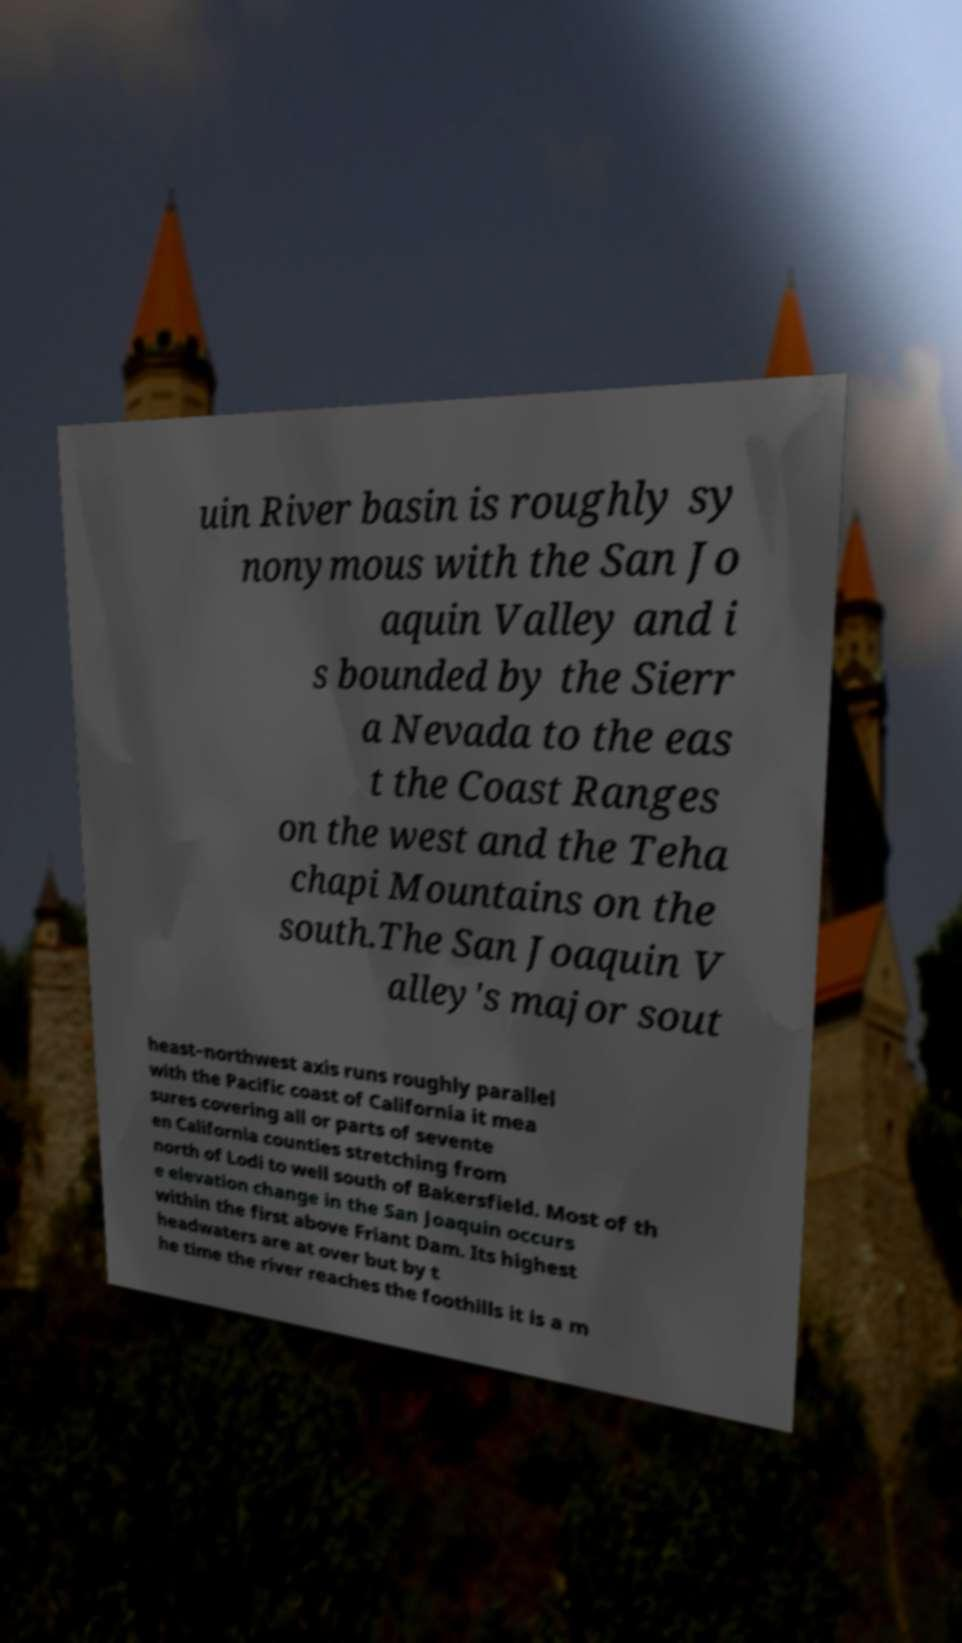There's text embedded in this image that I need extracted. Can you transcribe it verbatim? uin River basin is roughly sy nonymous with the San Jo aquin Valley and i s bounded by the Sierr a Nevada to the eas t the Coast Ranges on the west and the Teha chapi Mountains on the south.The San Joaquin V alley's major sout heast–northwest axis runs roughly parallel with the Pacific coast of California it mea sures covering all or parts of sevente en California counties stretching from north of Lodi to well south of Bakersfield. Most of th e elevation change in the San Joaquin occurs within the first above Friant Dam. Its highest headwaters are at over but by t he time the river reaches the foothills it is a m 